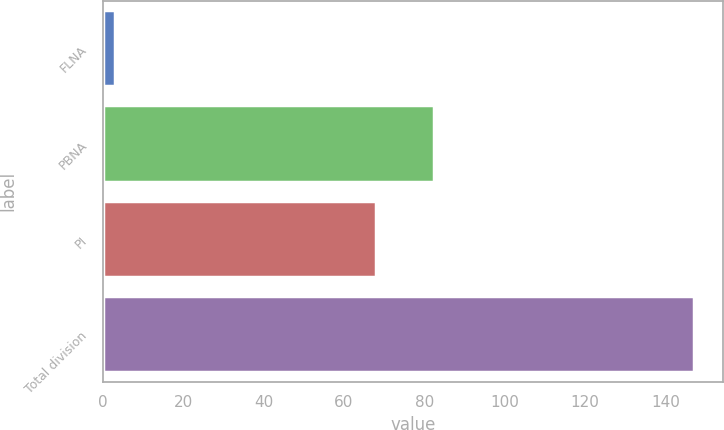Convert chart to OTSL. <chart><loc_0><loc_0><loc_500><loc_500><bar_chart><fcel>FLNA<fcel>PBNA<fcel>PI<fcel>Total division<nl><fcel>3<fcel>82.4<fcel>68<fcel>147<nl></chart> 